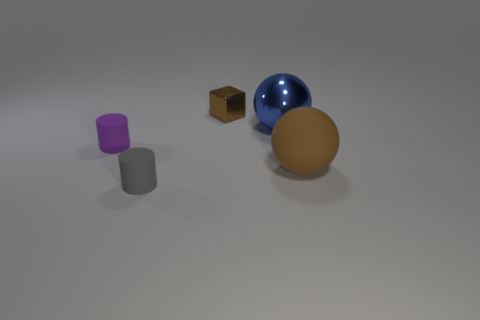Add 4 cylinders. How many objects exist? 9 Subtract all cylinders. How many objects are left? 3 Subtract all small cylinders. Subtract all red shiny cylinders. How many objects are left? 3 Add 3 large shiny spheres. How many large shiny spheres are left? 4 Add 2 blue balls. How many blue balls exist? 3 Subtract 1 purple cylinders. How many objects are left? 4 